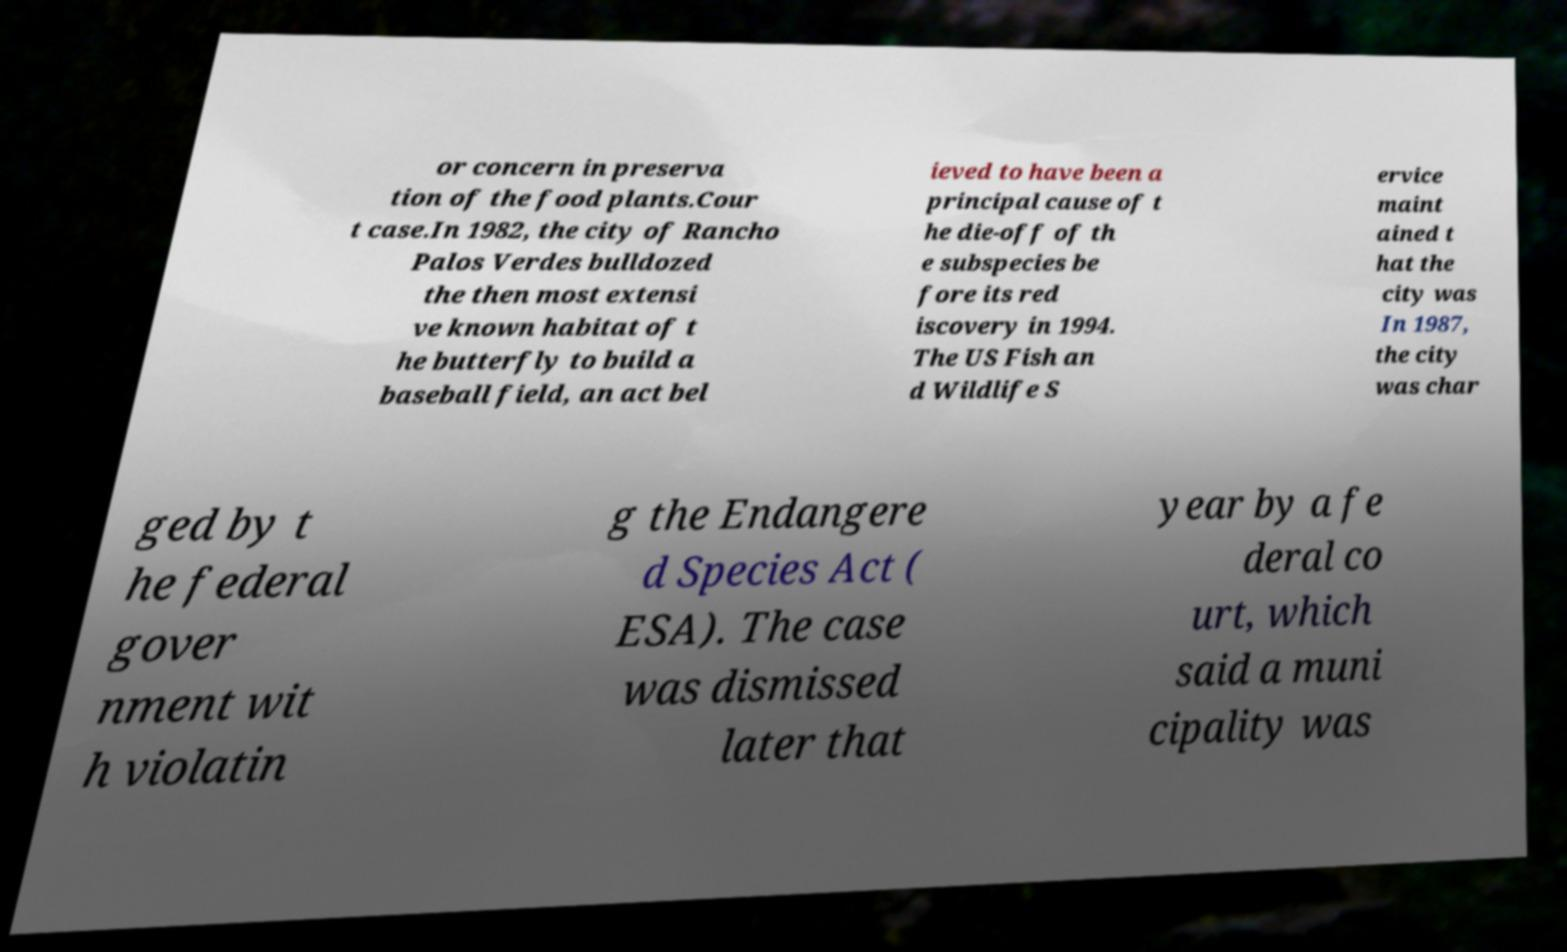There's text embedded in this image that I need extracted. Can you transcribe it verbatim? or concern in preserva tion of the food plants.Cour t case.In 1982, the city of Rancho Palos Verdes bulldozed the then most extensi ve known habitat of t he butterfly to build a baseball field, an act bel ieved to have been a principal cause of t he die-off of th e subspecies be fore its red iscovery in 1994. The US Fish an d Wildlife S ervice maint ained t hat the city was In 1987, the city was char ged by t he federal gover nment wit h violatin g the Endangere d Species Act ( ESA). The case was dismissed later that year by a fe deral co urt, which said a muni cipality was 